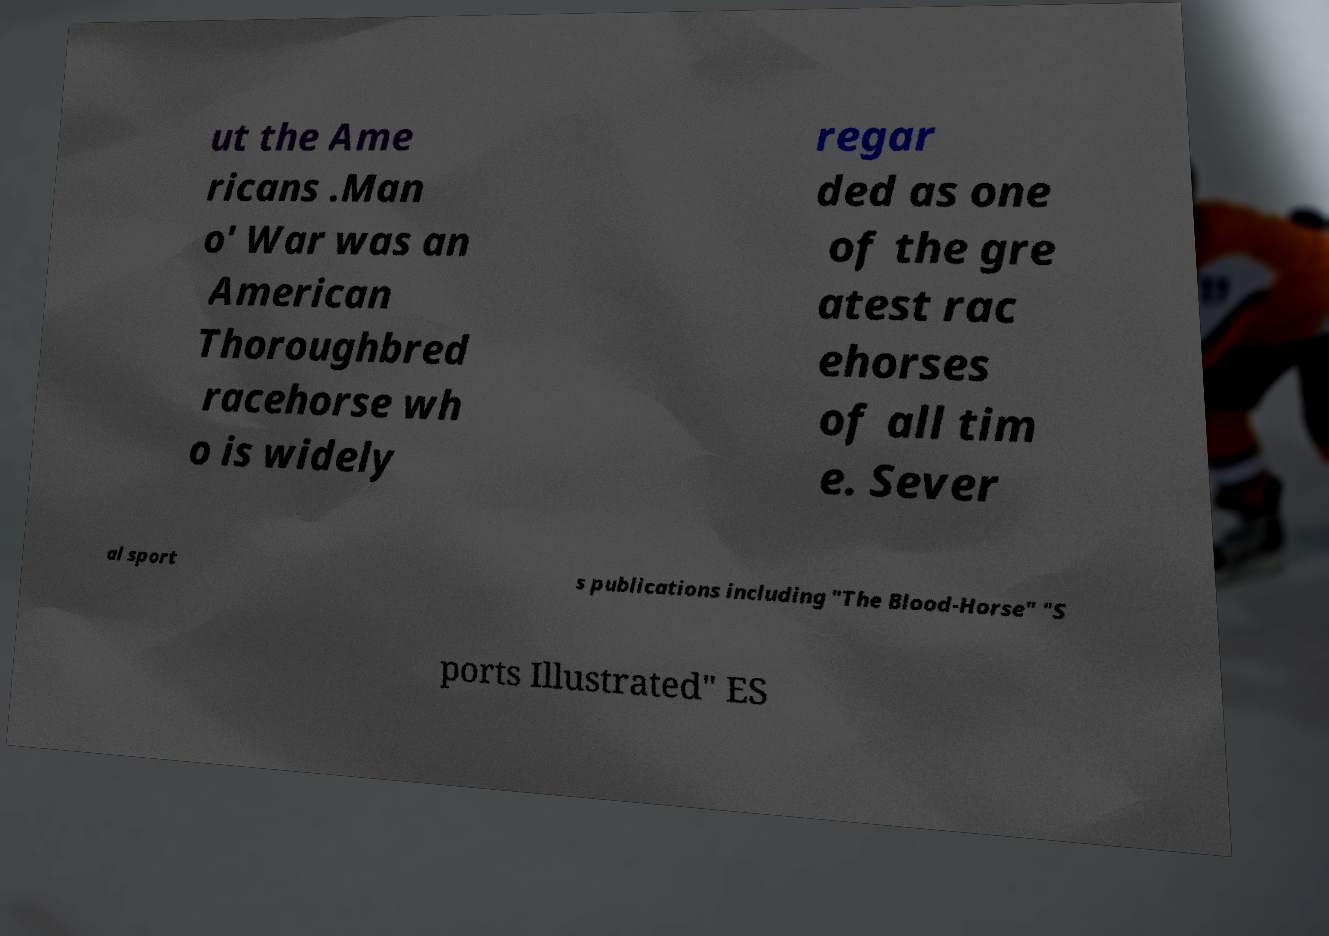Please identify and transcribe the text found in this image. ut the Ame ricans .Man o' War was an American Thoroughbred racehorse wh o is widely regar ded as one of the gre atest rac ehorses of all tim e. Sever al sport s publications including "The Blood-Horse" "S ports Illustrated" ES 